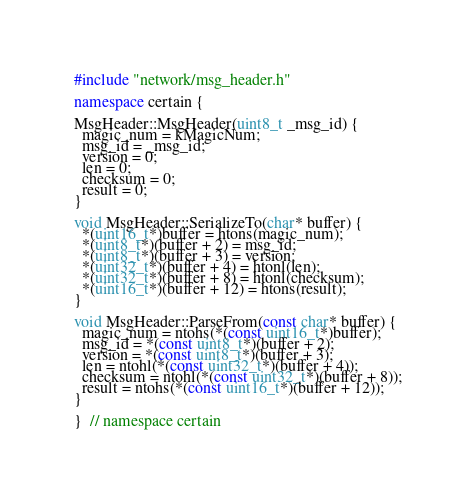Convert code to text. <code><loc_0><loc_0><loc_500><loc_500><_C++_>#include "network/msg_header.h"

namespace certain {

MsgHeader::MsgHeader(uint8_t _msg_id) {
  magic_num = kMagicNum;
  msg_id = _msg_id;
  version = 0;
  len = 0;
  checksum = 0;
  result = 0;
}

void MsgHeader::SerializeTo(char* buffer) {
  *(uint16_t*)buffer = htons(magic_num);
  *(uint8_t*)(buffer + 2) = msg_id;
  *(uint8_t*)(buffer + 3) = version;
  *(uint32_t*)(buffer + 4) = htonl(len);
  *(uint32_t*)(buffer + 8) = htonl(checksum);
  *(uint16_t*)(buffer + 12) = htons(result);
}

void MsgHeader::ParseFrom(const char* buffer) {
  magic_num = ntohs(*(const uint16_t*)buffer);
  msg_id = *(const uint8_t*)(buffer + 2);
  version = *(const uint8_t*)(buffer + 3);
  len = ntohl(*(const uint32_t*)(buffer + 4));
  checksum = ntohl(*(const uint32_t*)(buffer + 8));
  result = ntohs(*(const uint16_t*)(buffer + 12));
}

}  // namespace certain
</code> 